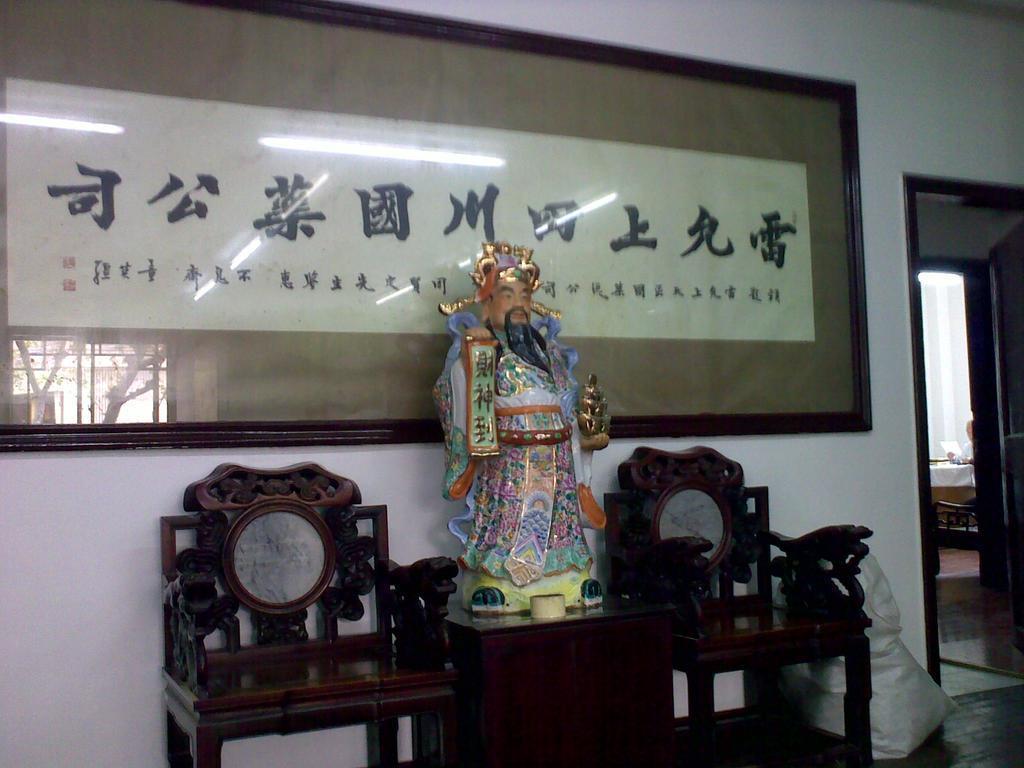Describe this image in one or two sentences. There is a statue placed on the table. Beside there are some chairs. In the background there is a photo frame attached to the wall here. In the right side there is a bag and a door here. 